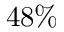<formula> <loc_0><loc_0><loc_500><loc_500>4 8 \%</formula> 